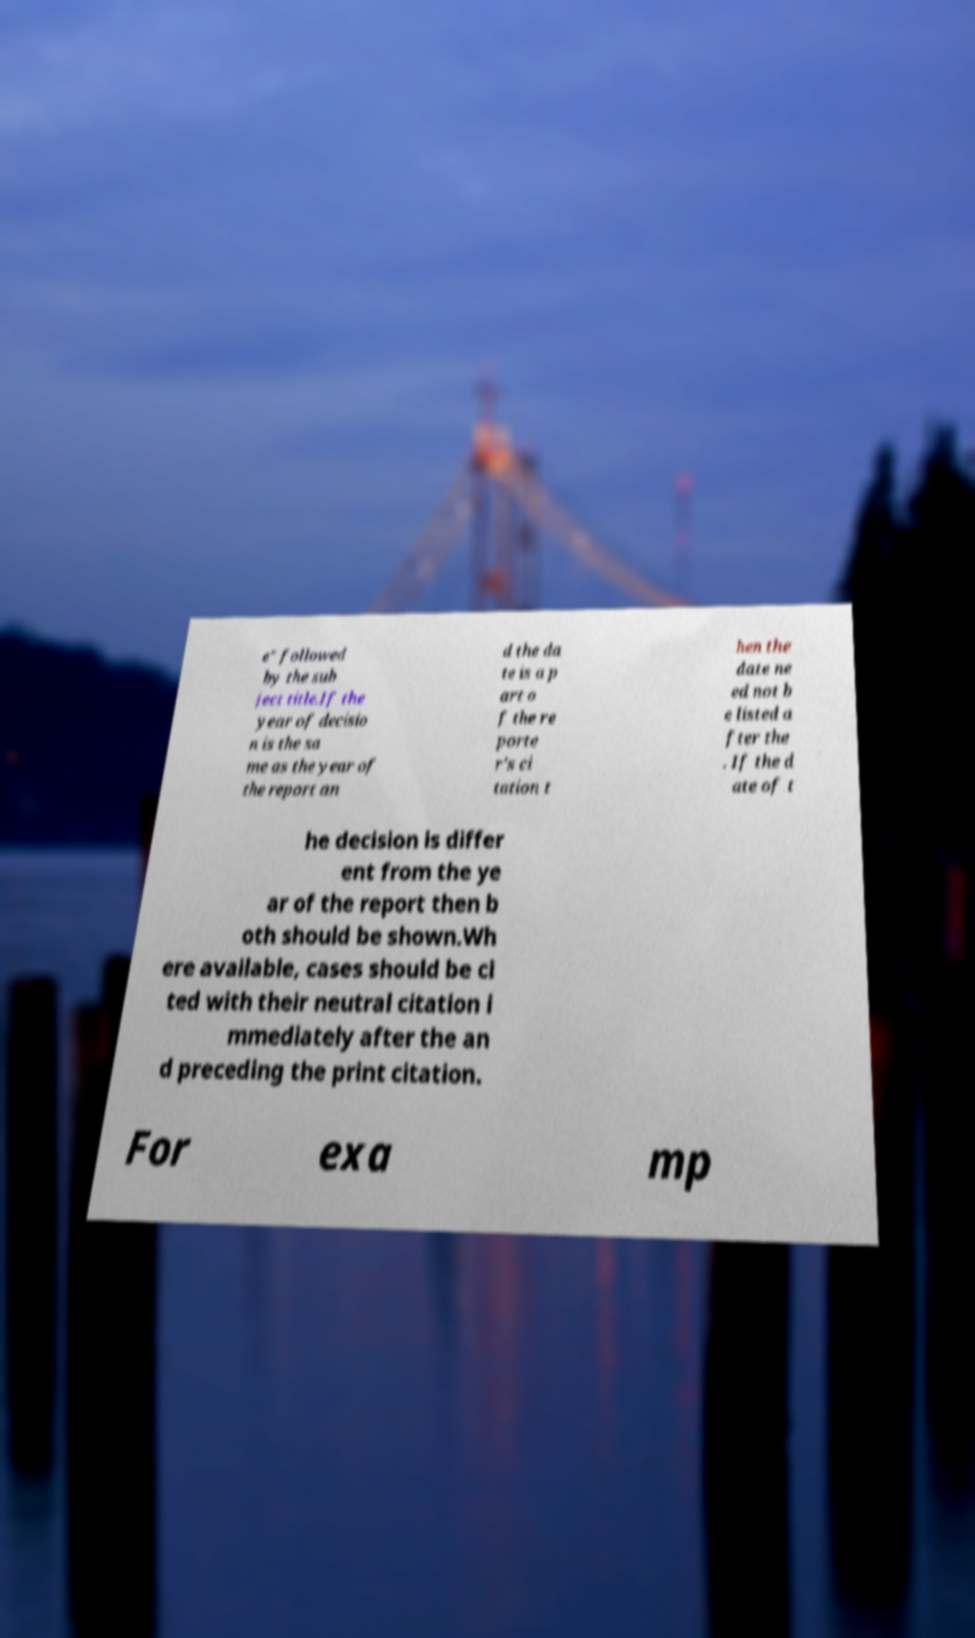Could you extract and type out the text from this image? e" followed by the sub ject title.If the year of decisio n is the sa me as the year of the report an d the da te is a p art o f the re porte r's ci tation t hen the date ne ed not b e listed a fter the . If the d ate of t he decision is differ ent from the ye ar of the report then b oth should be shown.Wh ere available, cases should be ci ted with their neutral citation i mmediately after the an d preceding the print citation. For exa mp 